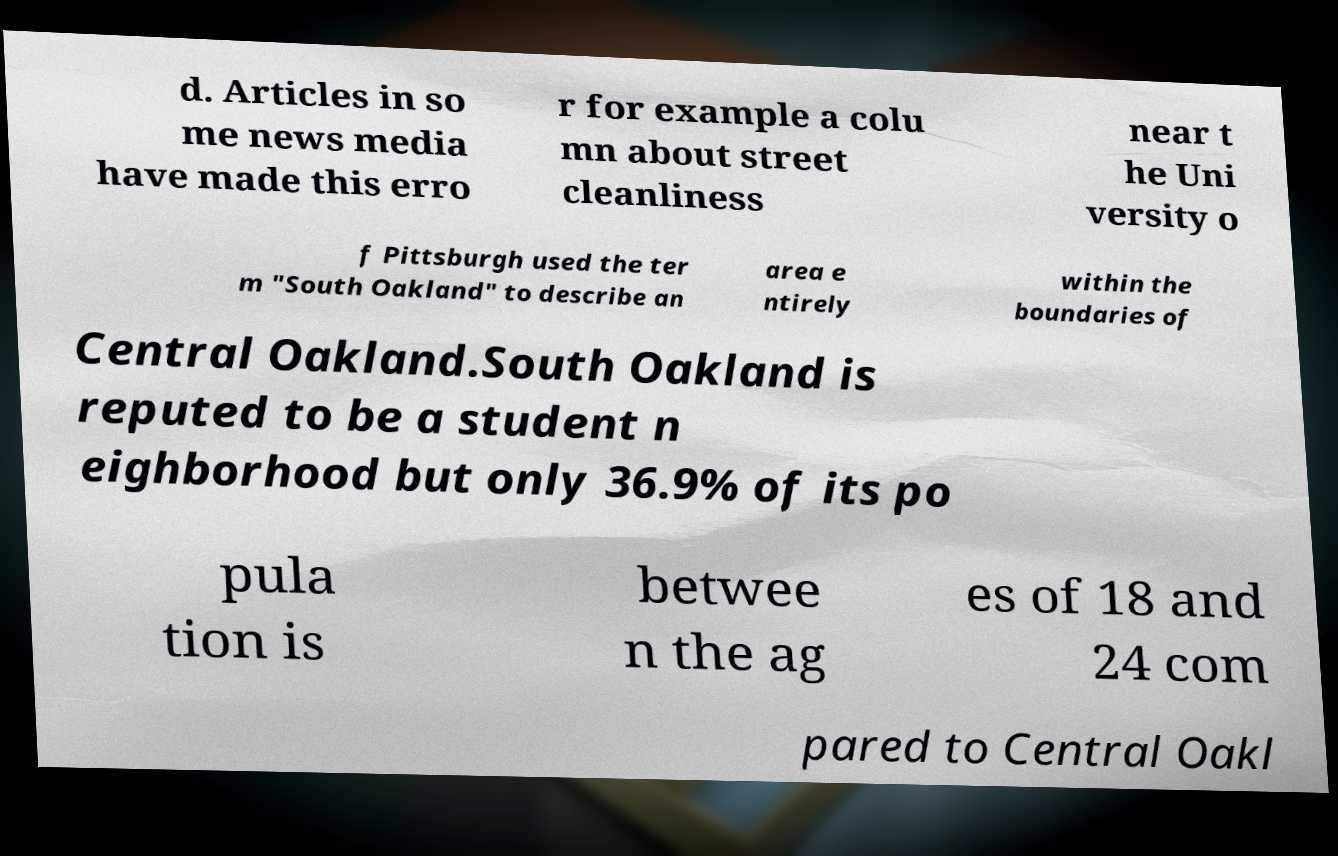What messages or text are displayed in this image? I need them in a readable, typed format. d. Articles in so me news media have made this erro r for example a colu mn about street cleanliness near t he Uni versity o f Pittsburgh used the ter m "South Oakland" to describe an area e ntirely within the boundaries of Central Oakland.South Oakland is reputed to be a student n eighborhood but only 36.9% of its po pula tion is betwee n the ag es of 18 and 24 com pared to Central Oakl 